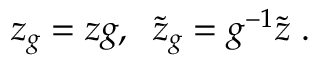<formula> <loc_0><loc_0><loc_500><loc_500>z _ { g } = z g , \, \tilde { z } _ { g } = g ^ { - 1 } \tilde { z } \, .</formula> 